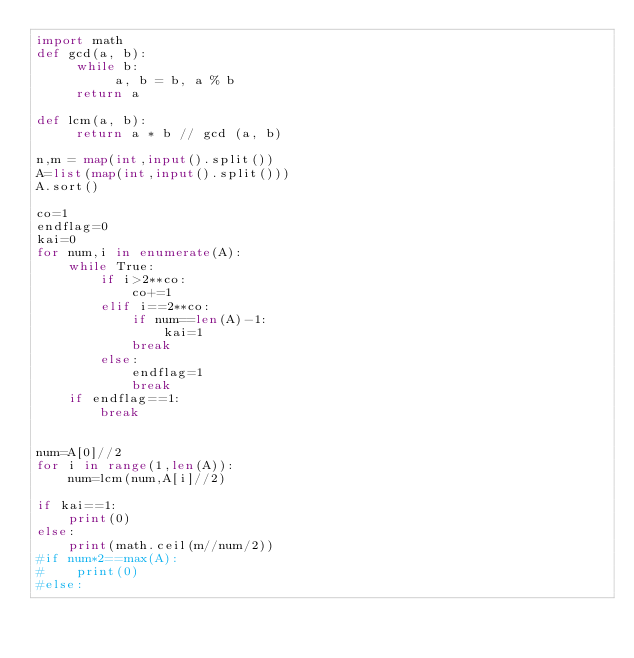<code> <loc_0><loc_0><loc_500><loc_500><_Python_>import math
def gcd(a, b):
     while b:
          a, b = b, a % b
     return a

def lcm(a, b):
     return a * b // gcd (a, b)

n,m = map(int,input().split())
A=list(map(int,input().split()))
A.sort()

co=1
endflag=0
kai=0
for num,i in enumerate(A):
    while True:
        if i>2**co:
            co+=1
        elif i==2**co:
            if num==len(A)-1:
                kai=1
            break
        else:
            endflag=1
            break
    if endflag==1:
        break
    

num=A[0]//2
for i in range(1,len(A)):
    num=lcm(num,A[i]//2)

if kai==1:
    print(0)
else:
    print(math.ceil(m//num/2))
#if num*2==max(A):
#    print(0)
#else:


</code> 